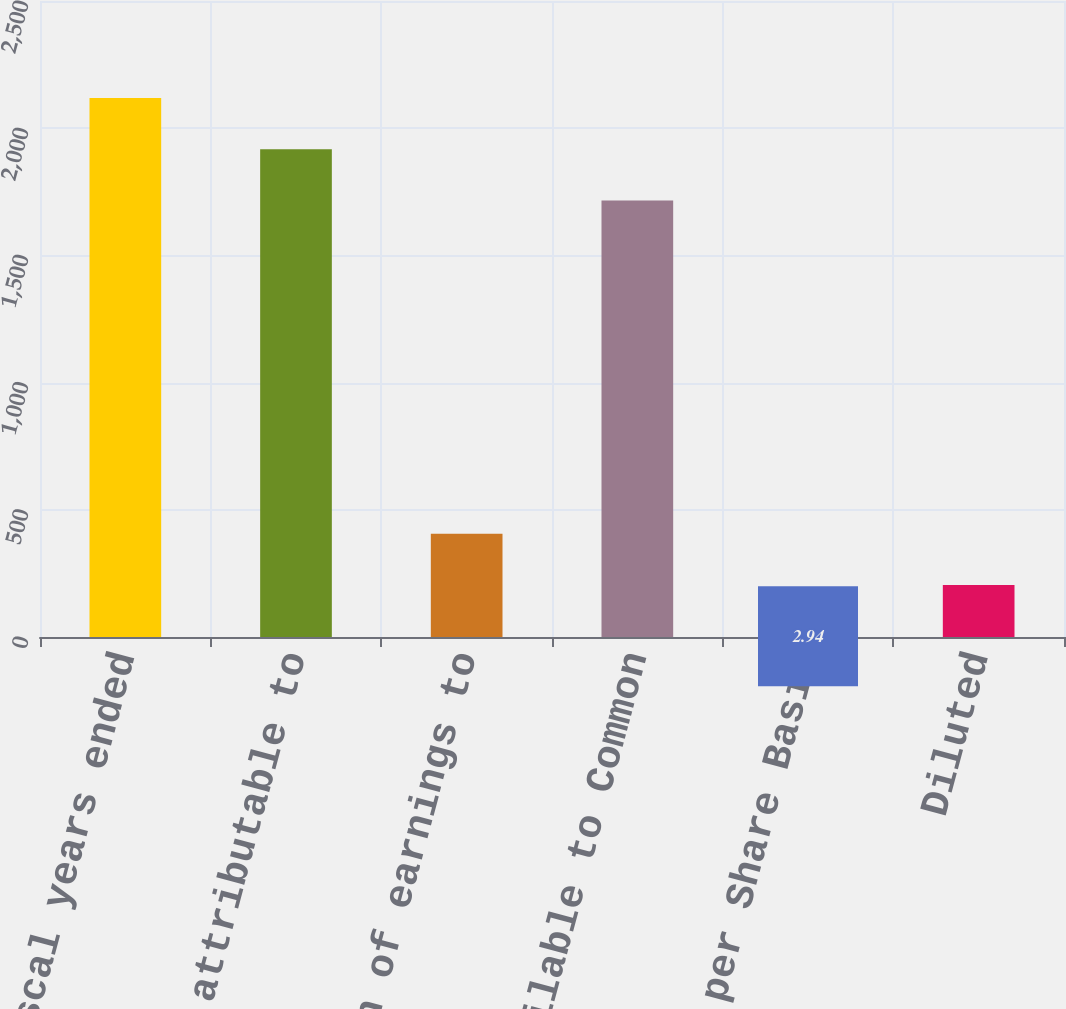Convert chart to OTSL. <chart><loc_0><loc_0><loc_500><loc_500><bar_chart><fcel>for the fiscal years ended<fcel>Net income attributable to<fcel>Less allocation of earnings to<fcel>Net Income Available to Common<fcel>Earnings per Share Basic<fcel>Diluted<nl><fcel>2118.42<fcel>1917.11<fcel>405.56<fcel>1715.8<fcel>2.94<fcel>204.25<nl></chart> 